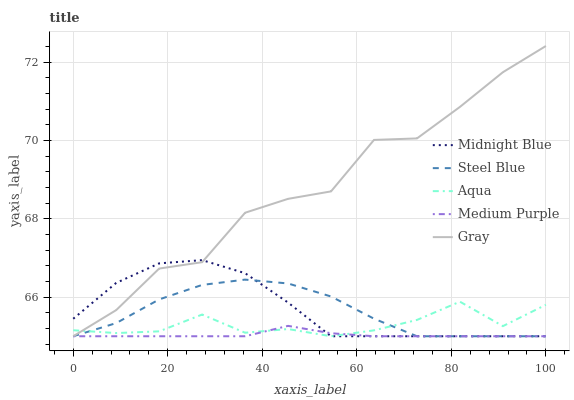Does Medium Purple have the minimum area under the curve?
Answer yes or no. Yes. Does Gray have the maximum area under the curve?
Answer yes or no. Yes. Does Aqua have the minimum area under the curve?
Answer yes or no. No. Does Aqua have the maximum area under the curve?
Answer yes or no. No. Is Medium Purple the smoothest?
Answer yes or no. Yes. Is Gray the roughest?
Answer yes or no. Yes. Is Aqua the smoothest?
Answer yes or no. No. Is Aqua the roughest?
Answer yes or no. No. Does Gray have the highest value?
Answer yes or no. Yes. Does Aqua have the highest value?
Answer yes or no. No. Does Steel Blue intersect Midnight Blue?
Answer yes or no. Yes. Is Steel Blue less than Midnight Blue?
Answer yes or no. No. Is Steel Blue greater than Midnight Blue?
Answer yes or no. No. 